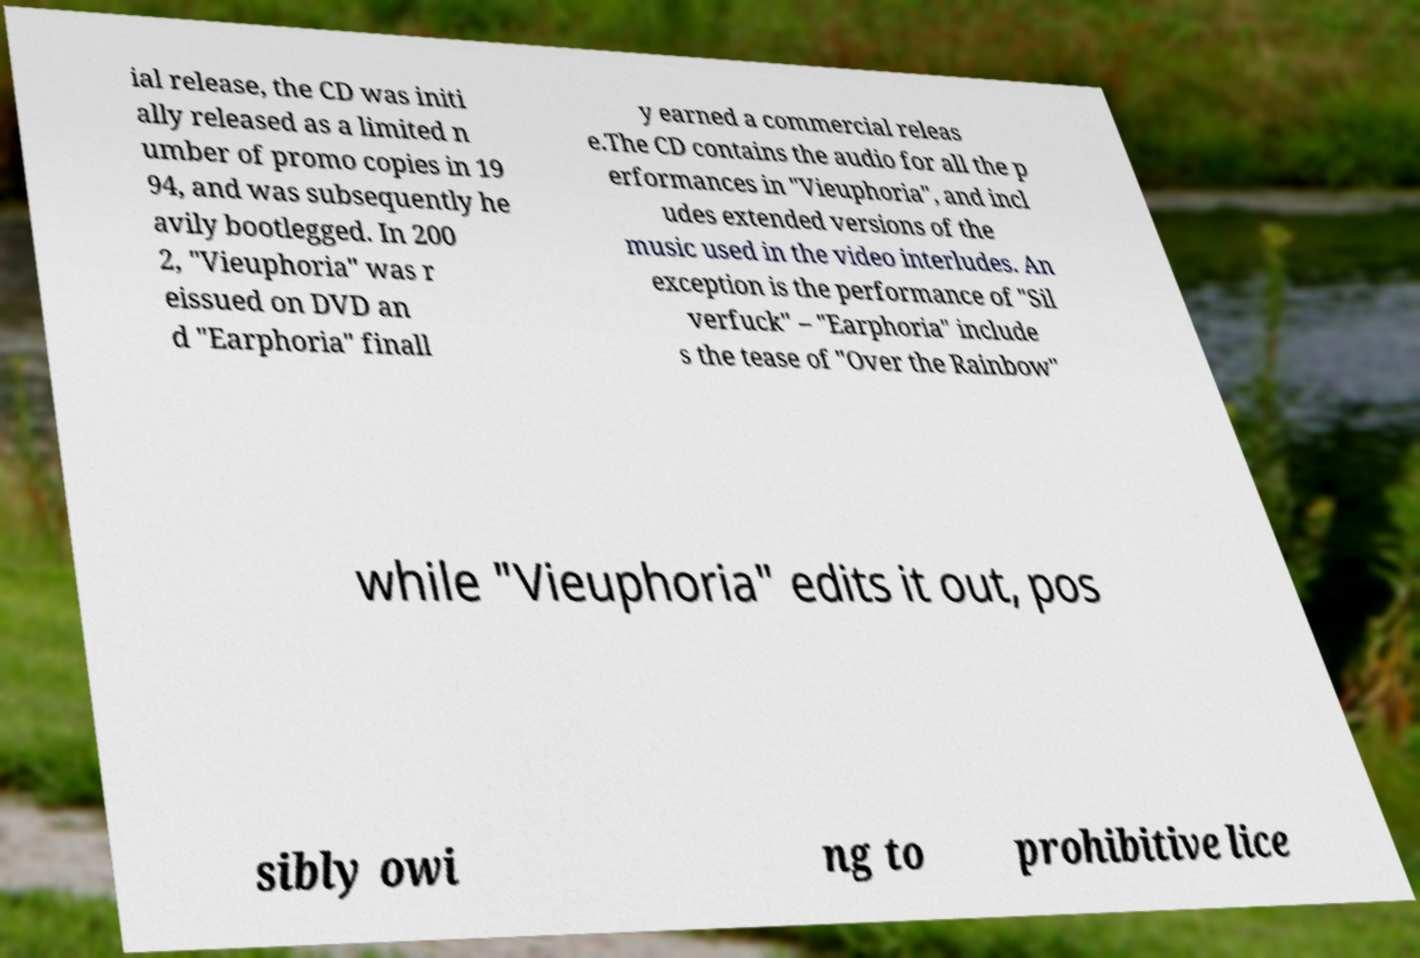I need the written content from this picture converted into text. Can you do that? ial release, the CD was initi ally released as a limited n umber of promo copies in 19 94, and was subsequently he avily bootlegged. In 200 2, "Vieuphoria" was r eissued on DVD an d "Earphoria" finall y earned a commercial releas e.The CD contains the audio for all the p erformances in "Vieuphoria", and incl udes extended versions of the music used in the video interludes. An exception is the performance of "Sil verfuck" – "Earphoria" include s the tease of "Over the Rainbow" while "Vieuphoria" edits it out, pos sibly owi ng to prohibitive lice 